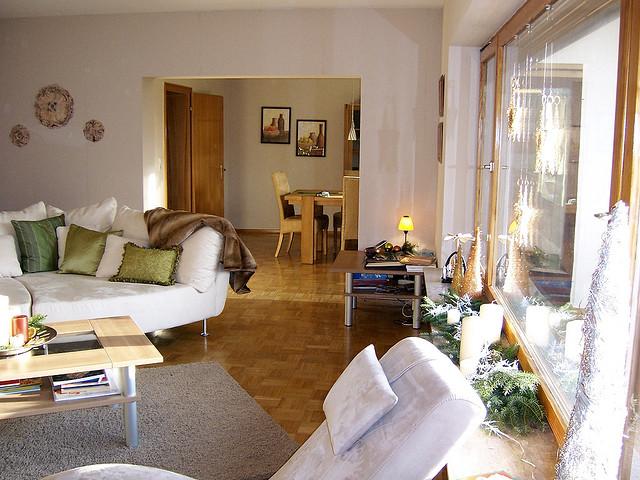Are there any paintings on the wall?
Short answer required. Yes. Is there a carpet underneath the table on the left?
Concise answer only. Yes. What color is the couch?
Concise answer only. White. 